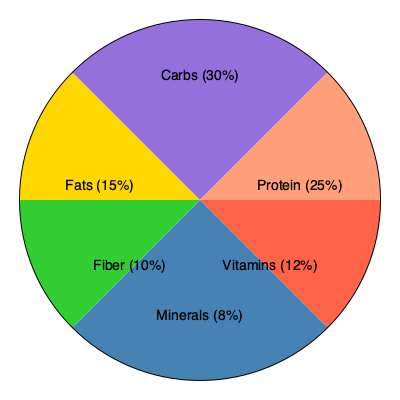Based on the pie chart showing recommended daily nutrient intake for seniors, which two nutrients combined make up more than half of the total recommended intake? To determine which two nutrients combined make up more than half of the total recommended intake, we need to:

1. Identify the percentages for each nutrient:
   - Protein: 25%
   - Carbs: 30%
   - Fats: 15%
   - Fiber: 10%
   - Vitamins: 12%
   - Minerals: 8%

2. Find the two largest percentages:
   - Carbs: 30%
   - Protein: 25%

3. Add these two percentages:
   $30\% + 25\% = 55\%$

4. Check if the sum is greater than 50%:
   $55\% > 50\%$

Therefore, carbohydrates and protein combined make up more than half (55%) of the total recommended daily nutrient intake for seniors.
Answer: Carbohydrates and protein 